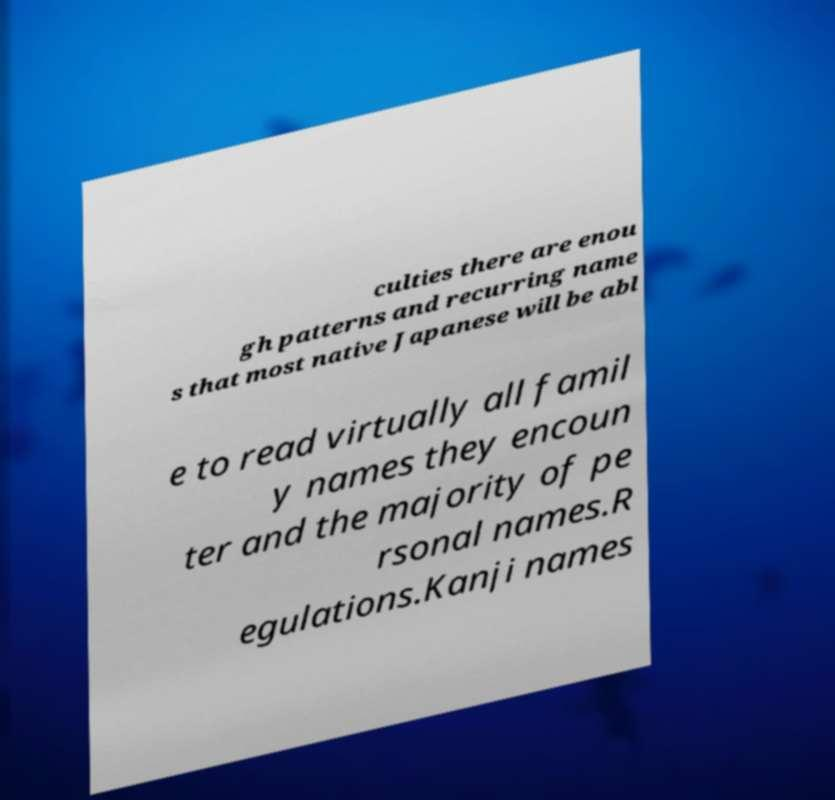For documentation purposes, I need the text within this image transcribed. Could you provide that? culties there are enou gh patterns and recurring name s that most native Japanese will be abl e to read virtually all famil y names they encoun ter and the majority of pe rsonal names.R egulations.Kanji names 